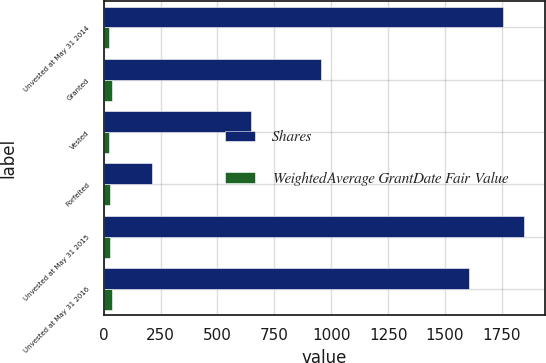Convert chart. <chart><loc_0><loc_0><loc_500><loc_500><stacked_bar_chart><ecel><fcel>Unvested at May 31 2014<fcel>Granted<fcel>Vested<fcel>Forfeited<fcel>Unvested at May 31 2015<fcel>Unvested at May 31 2016<nl><fcel>Shares<fcel>1754<fcel>954<fcel>648<fcel>212<fcel>1848<fcel>1606<nl><fcel>WeightedAverage GrantDate Fair Value<fcel>22.72<fcel>36.21<fcel>23.17<fcel>27.03<fcel>28.97<fcel>37.25<nl></chart> 